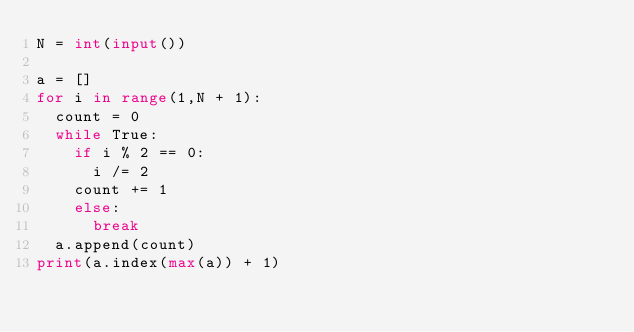<code> <loc_0><loc_0><loc_500><loc_500><_Python_>N = int(input())

a = []
for i in range(1,N + 1):
  count = 0
  while True:
    if i % 2 == 0:
      i /= 2
    count += 1
    else:
      break
  a.append(count)
print(a.index(max(a)) + 1)
</code> 